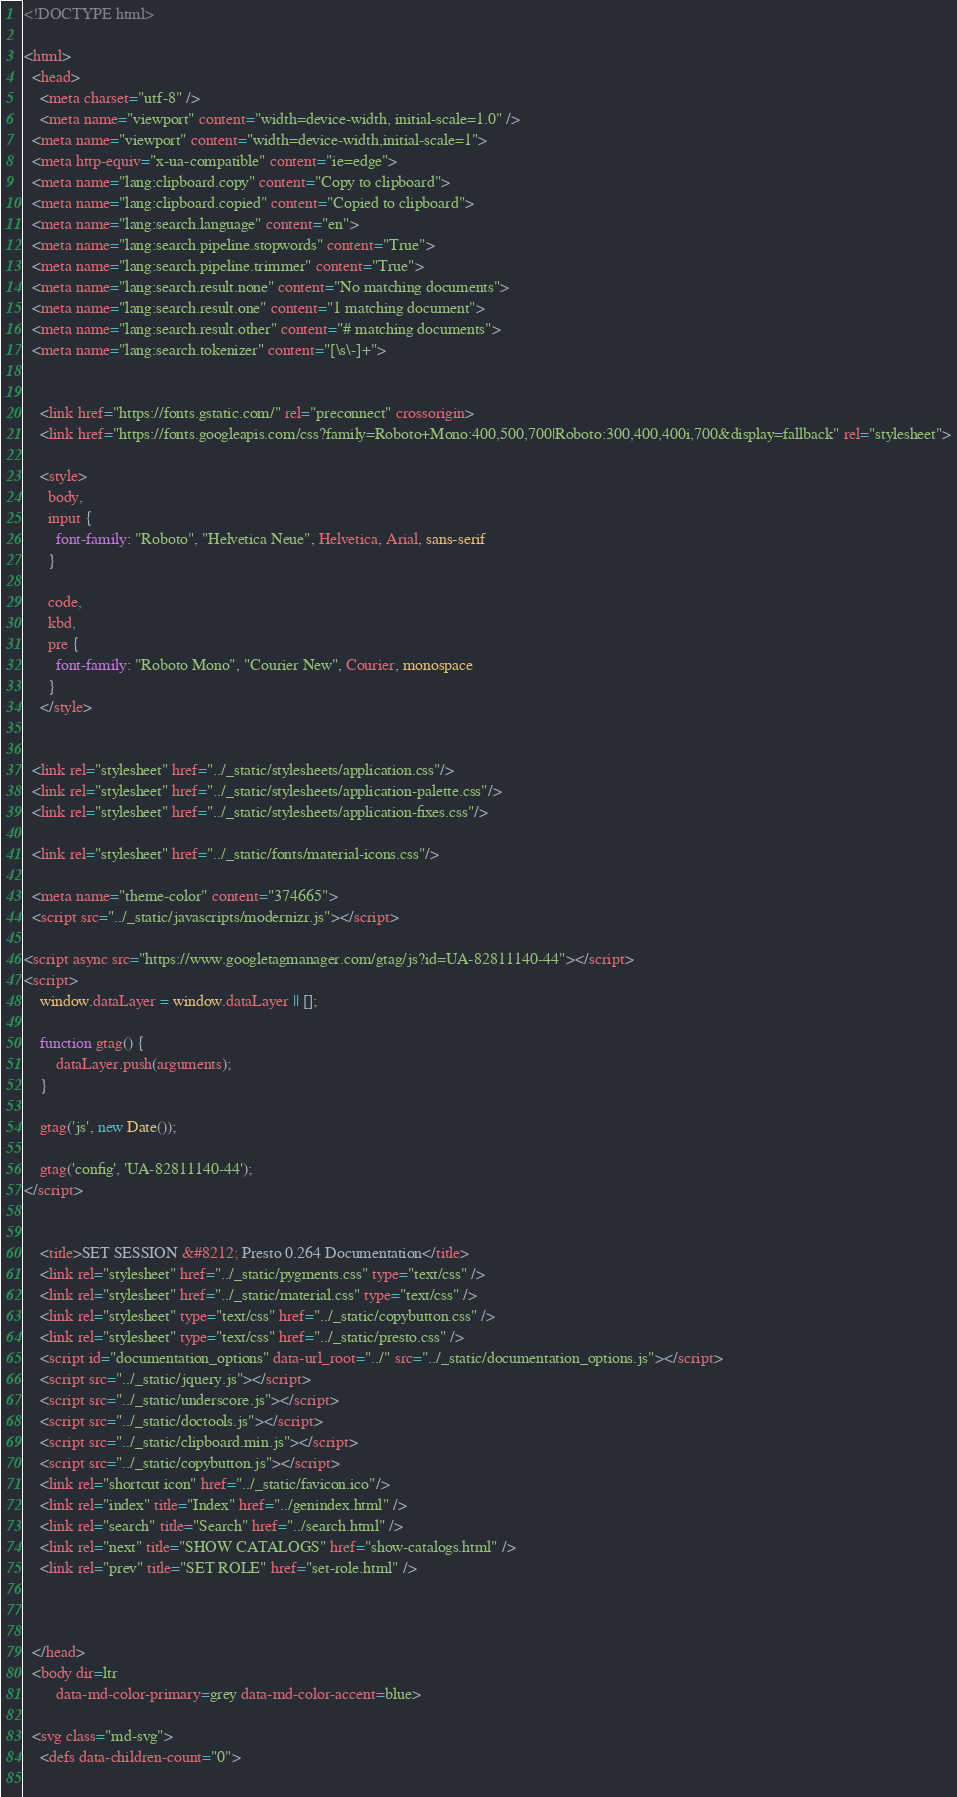<code> <loc_0><loc_0><loc_500><loc_500><_HTML_>
<!DOCTYPE html>

<html>
  <head>
    <meta charset="utf-8" />
    <meta name="viewport" content="width=device-width, initial-scale=1.0" />
  <meta name="viewport" content="width=device-width,initial-scale=1">
  <meta http-equiv="x-ua-compatible" content="ie=edge">
  <meta name="lang:clipboard.copy" content="Copy to clipboard">
  <meta name="lang:clipboard.copied" content="Copied to clipboard">
  <meta name="lang:search.language" content="en">
  <meta name="lang:search.pipeline.stopwords" content="True">
  <meta name="lang:search.pipeline.trimmer" content="True">
  <meta name="lang:search.result.none" content="No matching documents">
  <meta name="lang:search.result.one" content="1 matching document">
  <meta name="lang:search.result.other" content="# matching documents">
  <meta name="lang:search.tokenizer" content="[\s\-]+">

  
    <link href="https://fonts.gstatic.com/" rel="preconnect" crossorigin>
    <link href="https://fonts.googleapis.com/css?family=Roboto+Mono:400,500,700|Roboto:300,400,400i,700&display=fallback" rel="stylesheet">

    <style>
      body,
      input {
        font-family: "Roboto", "Helvetica Neue", Helvetica, Arial, sans-serif
      }

      code,
      kbd,
      pre {
        font-family: "Roboto Mono", "Courier New", Courier, monospace
      }
    </style>
  

  <link rel="stylesheet" href="../_static/stylesheets/application.css"/>
  <link rel="stylesheet" href="../_static/stylesheets/application-palette.css"/>
  <link rel="stylesheet" href="../_static/stylesheets/application-fixes.css"/>
  
  <link rel="stylesheet" href="../_static/fonts/material-icons.css"/>
  
  <meta name="theme-color" content="374665">
  <script src="../_static/javascripts/modernizr.js"></script>
  
<script async src="https://www.googletagmanager.com/gtag/js?id=UA-82811140-44"></script>
<script>
    window.dataLayer = window.dataLayer || [];

    function gtag() {
        dataLayer.push(arguments);
    }

    gtag('js', new Date());

    gtag('config', 'UA-82811140-44');
</script>
  
  
    <title>SET SESSION &#8212; Presto 0.264 Documentation</title>
    <link rel="stylesheet" href="../_static/pygments.css" type="text/css" />
    <link rel="stylesheet" href="../_static/material.css" type="text/css" />
    <link rel="stylesheet" type="text/css" href="../_static/copybutton.css" />
    <link rel="stylesheet" type="text/css" href="../_static/presto.css" />
    <script id="documentation_options" data-url_root="../" src="../_static/documentation_options.js"></script>
    <script src="../_static/jquery.js"></script>
    <script src="../_static/underscore.js"></script>
    <script src="../_static/doctools.js"></script>
    <script src="../_static/clipboard.min.js"></script>
    <script src="../_static/copybutton.js"></script>
    <link rel="shortcut icon" href="../_static/favicon.ico"/>
    <link rel="index" title="Index" href="../genindex.html" />
    <link rel="search" title="Search" href="../search.html" />
    <link rel="next" title="SHOW CATALOGS" href="show-catalogs.html" />
    <link rel="prev" title="SET ROLE" href="set-role.html" />
  
   

  </head>
  <body dir=ltr
        data-md-color-primary=grey data-md-color-accent=blue>
  
  <svg class="md-svg">
    <defs data-children-count="0">
      </code> 